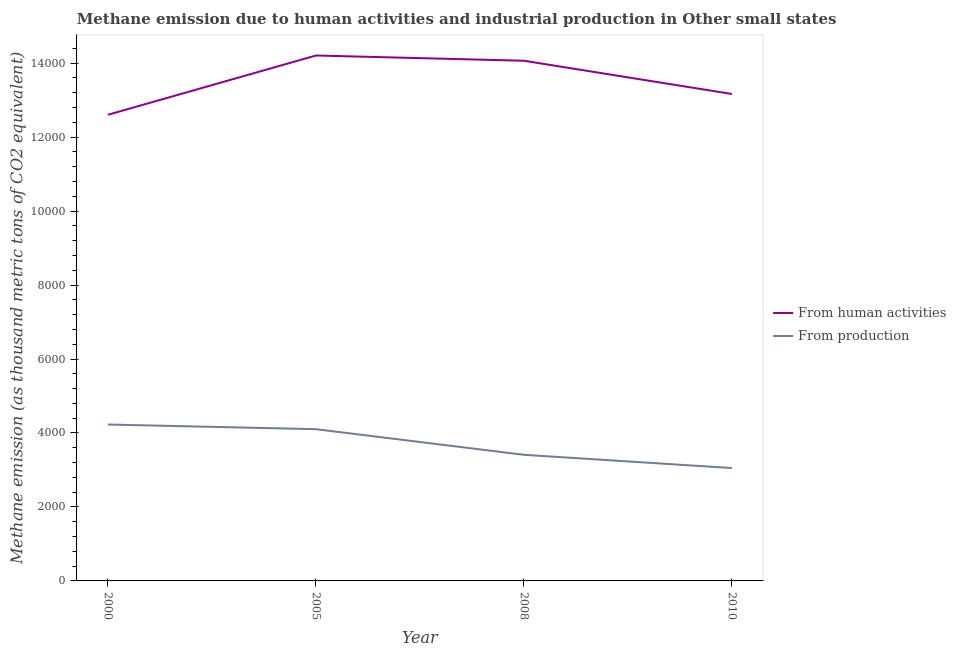How many different coloured lines are there?
Provide a succinct answer. 2. Is the number of lines equal to the number of legend labels?
Ensure brevity in your answer.  Yes. What is the amount of emissions from human activities in 2008?
Ensure brevity in your answer.  1.41e+04. Across all years, what is the maximum amount of emissions from human activities?
Ensure brevity in your answer.  1.42e+04. Across all years, what is the minimum amount of emissions generated from industries?
Ensure brevity in your answer.  3052.1. What is the total amount of emissions from human activities in the graph?
Give a very brief answer. 5.40e+04. What is the difference between the amount of emissions generated from industries in 2005 and that in 2008?
Offer a very short reply. 692.8. What is the difference between the amount of emissions from human activities in 2008 and the amount of emissions generated from industries in 2005?
Ensure brevity in your answer.  9962.4. What is the average amount of emissions from human activities per year?
Give a very brief answer. 1.35e+04. In the year 2010, what is the difference between the amount of emissions generated from industries and amount of emissions from human activities?
Your response must be concise. -1.01e+04. In how many years, is the amount of emissions generated from industries greater than 7200 thousand metric tons?
Give a very brief answer. 0. What is the ratio of the amount of emissions from human activities in 2005 to that in 2010?
Your answer should be compact. 1.08. What is the difference between the highest and the second highest amount of emissions from human activities?
Keep it short and to the point. 142.1. What is the difference between the highest and the lowest amount of emissions generated from industries?
Make the answer very short. 1177.3. In how many years, is the amount of emissions generated from industries greater than the average amount of emissions generated from industries taken over all years?
Keep it short and to the point. 2. Is the sum of the amount of emissions generated from industries in 2005 and 2008 greater than the maximum amount of emissions from human activities across all years?
Offer a very short reply. No. Does the amount of emissions generated from industries monotonically increase over the years?
Provide a succinct answer. No. Is the amount of emissions generated from industries strictly less than the amount of emissions from human activities over the years?
Provide a short and direct response. Yes. Does the graph contain grids?
Your answer should be very brief. No. How many legend labels are there?
Keep it short and to the point. 2. What is the title of the graph?
Provide a succinct answer. Methane emission due to human activities and industrial production in Other small states. Does "Net savings(excluding particulate emission damage)" appear as one of the legend labels in the graph?
Offer a terse response. No. What is the label or title of the Y-axis?
Provide a succinct answer. Methane emission (as thousand metric tons of CO2 equivalent). What is the Methane emission (as thousand metric tons of CO2 equivalent) in From human activities in 2000?
Ensure brevity in your answer.  1.26e+04. What is the Methane emission (as thousand metric tons of CO2 equivalent) in From production in 2000?
Keep it short and to the point. 4229.4. What is the Methane emission (as thousand metric tons of CO2 equivalent) of From human activities in 2005?
Ensure brevity in your answer.  1.42e+04. What is the Methane emission (as thousand metric tons of CO2 equivalent) in From production in 2005?
Provide a succinct answer. 4102.8. What is the Methane emission (as thousand metric tons of CO2 equivalent) in From human activities in 2008?
Ensure brevity in your answer.  1.41e+04. What is the Methane emission (as thousand metric tons of CO2 equivalent) in From production in 2008?
Offer a very short reply. 3410. What is the Methane emission (as thousand metric tons of CO2 equivalent) in From human activities in 2010?
Offer a terse response. 1.32e+04. What is the Methane emission (as thousand metric tons of CO2 equivalent) in From production in 2010?
Offer a very short reply. 3052.1. Across all years, what is the maximum Methane emission (as thousand metric tons of CO2 equivalent) of From human activities?
Ensure brevity in your answer.  1.42e+04. Across all years, what is the maximum Methane emission (as thousand metric tons of CO2 equivalent) in From production?
Ensure brevity in your answer.  4229.4. Across all years, what is the minimum Methane emission (as thousand metric tons of CO2 equivalent) of From human activities?
Give a very brief answer. 1.26e+04. Across all years, what is the minimum Methane emission (as thousand metric tons of CO2 equivalent) of From production?
Ensure brevity in your answer.  3052.1. What is the total Methane emission (as thousand metric tons of CO2 equivalent) in From human activities in the graph?
Keep it short and to the point. 5.40e+04. What is the total Methane emission (as thousand metric tons of CO2 equivalent) of From production in the graph?
Provide a succinct answer. 1.48e+04. What is the difference between the Methane emission (as thousand metric tons of CO2 equivalent) in From human activities in 2000 and that in 2005?
Your answer should be compact. -1602.4. What is the difference between the Methane emission (as thousand metric tons of CO2 equivalent) in From production in 2000 and that in 2005?
Make the answer very short. 126.6. What is the difference between the Methane emission (as thousand metric tons of CO2 equivalent) in From human activities in 2000 and that in 2008?
Give a very brief answer. -1460.3. What is the difference between the Methane emission (as thousand metric tons of CO2 equivalent) of From production in 2000 and that in 2008?
Your response must be concise. 819.4. What is the difference between the Methane emission (as thousand metric tons of CO2 equivalent) of From human activities in 2000 and that in 2010?
Your answer should be compact. -561.8. What is the difference between the Methane emission (as thousand metric tons of CO2 equivalent) of From production in 2000 and that in 2010?
Your answer should be very brief. 1177.3. What is the difference between the Methane emission (as thousand metric tons of CO2 equivalent) in From human activities in 2005 and that in 2008?
Provide a succinct answer. 142.1. What is the difference between the Methane emission (as thousand metric tons of CO2 equivalent) of From production in 2005 and that in 2008?
Offer a very short reply. 692.8. What is the difference between the Methane emission (as thousand metric tons of CO2 equivalent) in From human activities in 2005 and that in 2010?
Offer a very short reply. 1040.6. What is the difference between the Methane emission (as thousand metric tons of CO2 equivalent) of From production in 2005 and that in 2010?
Your response must be concise. 1050.7. What is the difference between the Methane emission (as thousand metric tons of CO2 equivalent) in From human activities in 2008 and that in 2010?
Your answer should be compact. 898.5. What is the difference between the Methane emission (as thousand metric tons of CO2 equivalent) in From production in 2008 and that in 2010?
Make the answer very short. 357.9. What is the difference between the Methane emission (as thousand metric tons of CO2 equivalent) of From human activities in 2000 and the Methane emission (as thousand metric tons of CO2 equivalent) of From production in 2005?
Your response must be concise. 8502.1. What is the difference between the Methane emission (as thousand metric tons of CO2 equivalent) of From human activities in 2000 and the Methane emission (as thousand metric tons of CO2 equivalent) of From production in 2008?
Make the answer very short. 9194.9. What is the difference between the Methane emission (as thousand metric tons of CO2 equivalent) of From human activities in 2000 and the Methane emission (as thousand metric tons of CO2 equivalent) of From production in 2010?
Your response must be concise. 9552.8. What is the difference between the Methane emission (as thousand metric tons of CO2 equivalent) of From human activities in 2005 and the Methane emission (as thousand metric tons of CO2 equivalent) of From production in 2008?
Your response must be concise. 1.08e+04. What is the difference between the Methane emission (as thousand metric tons of CO2 equivalent) in From human activities in 2005 and the Methane emission (as thousand metric tons of CO2 equivalent) in From production in 2010?
Your response must be concise. 1.12e+04. What is the difference between the Methane emission (as thousand metric tons of CO2 equivalent) of From human activities in 2008 and the Methane emission (as thousand metric tons of CO2 equivalent) of From production in 2010?
Offer a terse response. 1.10e+04. What is the average Methane emission (as thousand metric tons of CO2 equivalent) of From human activities per year?
Your response must be concise. 1.35e+04. What is the average Methane emission (as thousand metric tons of CO2 equivalent) in From production per year?
Your response must be concise. 3698.57. In the year 2000, what is the difference between the Methane emission (as thousand metric tons of CO2 equivalent) of From human activities and Methane emission (as thousand metric tons of CO2 equivalent) of From production?
Offer a very short reply. 8375.5. In the year 2005, what is the difference between the Methane emission (as thousand metric tons of CO2 equivalent) of From human activities and Methane emission (as thousand metric tons of CO2 equivalent) of From production?
Make the answer very short. 1.01e+04. In the year 2008, what is the difference between the Methane emission (as thousand metric tons of CO2 equivalent) of From human activities and Methane emission (as thousand metric tons of CO2 equivalent) of From production?
Make the answer very short. 1.07e+04. In the year 2010, what is the difference between the Methane emission (as thousand metric tons of CO2 equivalent) of From human activities and Methane emission (as thousand metric tons of CO2 equivalent) of From production?
Your answer should be compact. 1.01e+04. What is the ratio of the Methane emission (as thousand metric tons of CO2 equivalent) of From human activities in 2000 to that in 2005?
Provide a succinct answer. 0.89. What is the ratio of the Methane emission (as thousand metric tons of CO2 equivalent) in From production in 2000 to that in 2005?
Your answer should be compact. 1.03. What is the ratio of the Methane emission (as thousand metric tons of CO2 equivalent) in From human activities in 2000 to that in 2008?
Ensure brevity in your answer.  0.9. What is the ratio of the Methane emission (as thousand metric tons of CO2 equivalent) of From production in 2000 to that in 2008?
Make the answer very short. 1.24. What is the ratio of the Methane emission (as thousand metric tons of CO2 equivalent) in From human activities in 2000 to that in 2010?
Your answer should be compact. 0.96. What is the ratio of the Methane emission (as thousand metric tons of CO2 equivalent) in From production in 2000 to that in 2010?
Ensure brevity in your answer.  1.39. What is the ratio of the Methane emission (as thousand metric tons of CO2 equivalent) of From human activities in 2005 to that in 2008?
Offer a terse response. 1.01. What is the ratio of the Methane emission (as thousand metric tons of CO2 equivalent) in From production in 2005 to that in 2008?
Keep it short and to the point. 1.2. What is the ratio of the Methane emission (as thousand metric tons of CO2 equivalent) of From human activities in 2005 to that in 2010?
Your answer should be very brief. 1.08. What is the ratio of the Methane emission (as thousand metric tons of CO2 equivalent) in From production in 2005 to that in 2010?
Your response must be concise. 1.34. What is the ratio of the Methane emission (as thousand metric tons of CO2 equivalent) of From human activities in 2008 to that in 2010?
Your answer should be compact. 1.07. What is the ratio of the Methane emission (as thousand metric tons of CO2 equivalent) in From production in 2008 to that in 2010?
Ensure brevity in your answer.  1.12. What is the difference between the highest and the second highest Methane emission (as thousand metric tons of CO2 equivalent) in From human activities?
Your answer should be compact. 142.1. What is the difference between the highest and the second highest Methane emission (as thousand metric tons of CO2 equivalent) of From production?
Keep it short and to the point. 126.6. What is the difference between the highest and the lowest Methane emission (as thousand metric tons of CO2 equivalent) in From human activities?
Offer a very short reply. 1602.4. What is the difference between the highest and the lowest Methane emission (as thousand metric tons of CO2 equivalent) of From production?
Make the answer very short. 1177.3. 